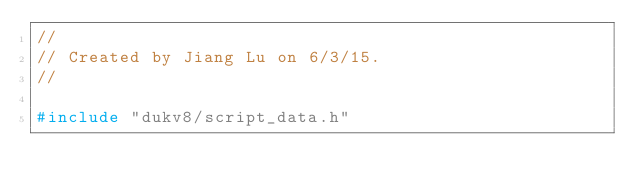Convert code to text. <code><loc_0><loc_0><loc_500><loc_500><_C++_>//
// Created by Jiang Lu on 6/3/15.
//

#include "dukv8/script_data.h"
</code> 